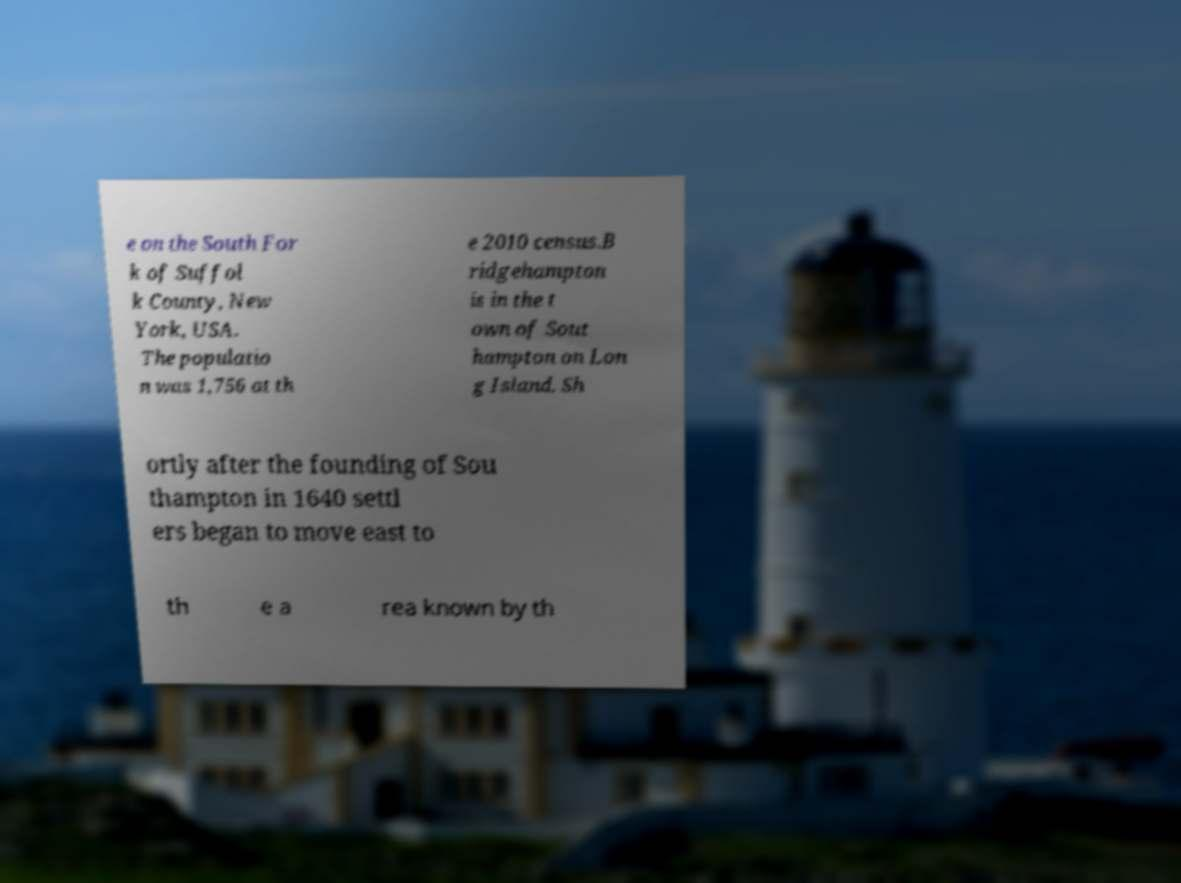What messages or text are displayed in this image? I need them in a readable, typed format. e on the South For k of Suffol k County, New York, USA. The populatio n was 1,756 at th e 2010 census.B ridgehampton is in the t own of Sout hampton on Lon g Island. Sh ortly after the founding of Sou thampton in 1640 settl ers began to move east to th e a rea known by th 